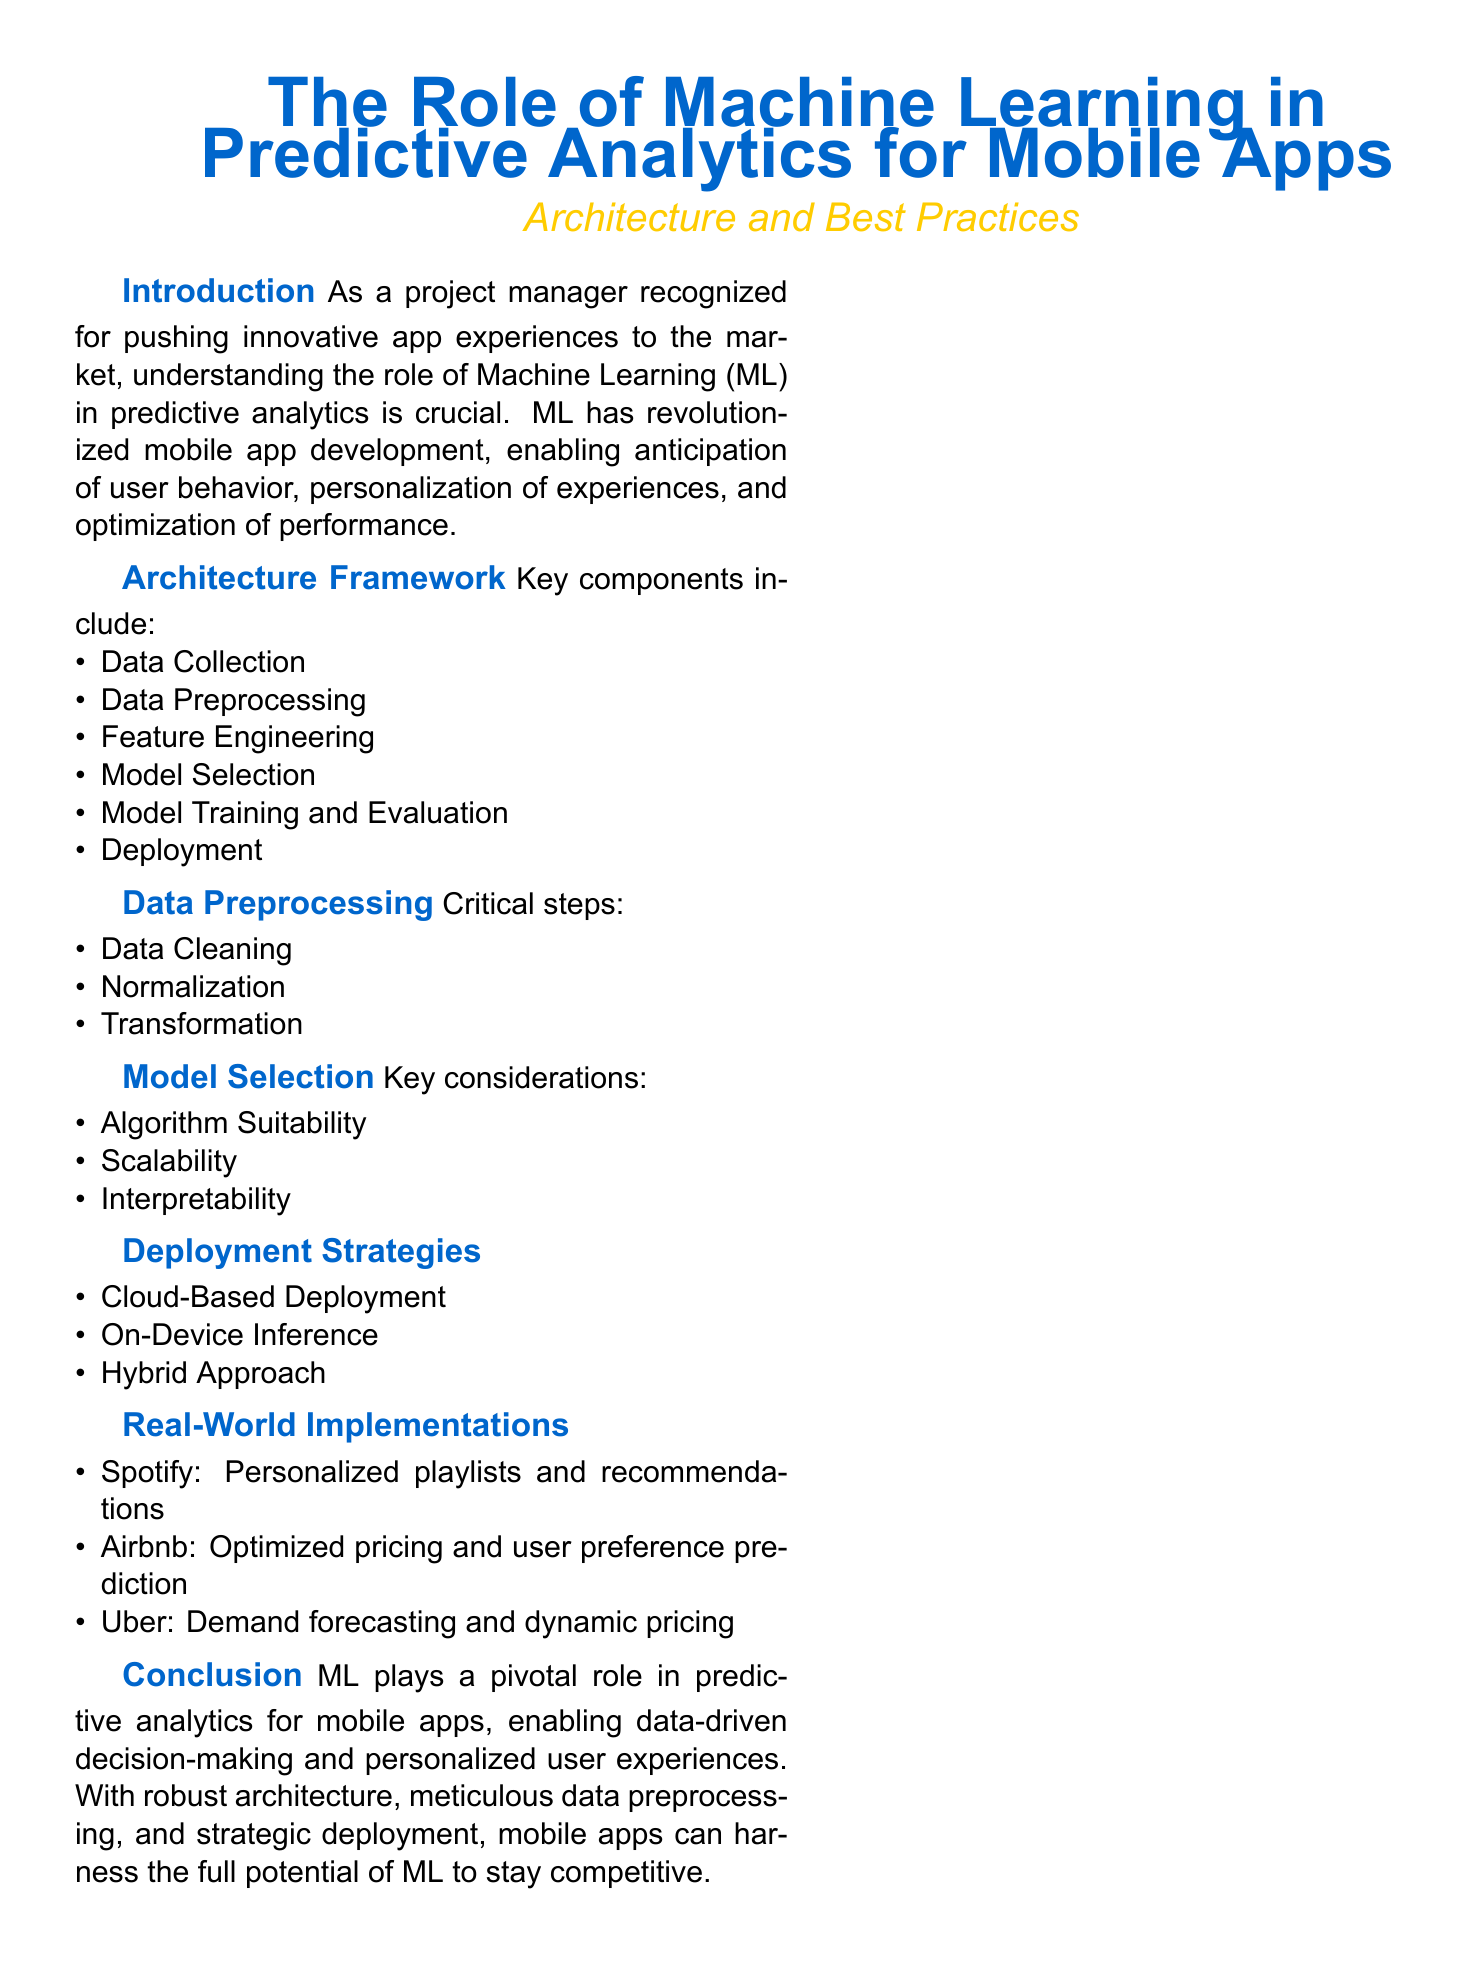What is the main subject of the whitepaper? The main subject of the whitepaper is about the integration of machine learning in mobile app development, specifically through predictive analytics.
Answer: Predictive Analytics for Mobile Apps What are the key components of the architecture framework? The document lists several key components which are necessary for the architecture framework of predictive analytics in mobile apps.
Answer: Data Collection, Data Preprocessing, Feature Engineering, Model Selection, Model Training and Evaluation, Deployment What type of deployment strategy does the document mention? Specific strategies for deploying machine learning models in mobile apps are highlighted in the whitepaper.
Answer: Cloud-Based Deployment Which company is associated with personalized playlists and recommendations? The document provides examples of companies that successfully implemented machine learning in their mobile apps, with Spotify mentioned for a specific application.
Answer: Spotify What are the steps involved in data preprocessing? The critical steps necessary for proper data handling before model training are outlined in the whitepaper.
Answer: Data Cleaning, Normalization, Transformation How does the document describe the role of machine learning in mobile apps? The document highlights the significance of machine learning in enhancing mobile app functionalities and user experience.
Answer: Enables data-driven decision-making and personalized user experiences What is a best practice recommendation for project managers? The document concludes with suggestions for project managers regarding machine learning and app experiences.
Answer: Explore advancements in ML technologies What is one of the real-world implementations mentioned in the whitepaper? The whitepaper provides real-world case studies demonstrating effective uses of machine learning, such as dynamic pricing.
Answer: Uber What key consideration is mentioned regarding model selection? The whitepaper outlines various important factors that should be considered when selecting a machine learning model.
Answer: Algorithm Suitability 